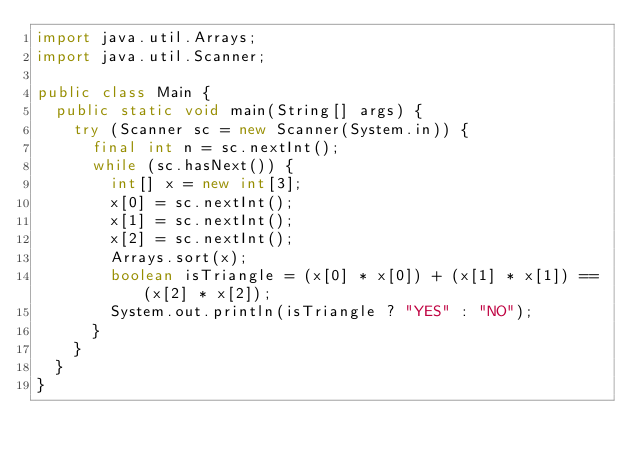<code> <loc_0><loc_0><loc_500><loc_500><_Java_>import java.util.Arrays;
import java.util.Scanner;

public class Main {
	public static void main(String[] args) {
		try (Scanner sc = new Scanner(System.in)) {
			final int n = sc.nextInt();
			while (sc.hasNext()) {
				int[] x = new int[3];
				x[0] = sc.nextInt();
				x[1] = sc.nextInt();
				x[2] = sc.nextInt();
				Arrays.sort(x);
				boolean isTriangle = (x[0] * x[0]) + (x[1] * x[1]) == (x[2] * x[2]);
				System.out.println(isTriangle ? "YES" : "NO");
			}
		}
	}
}</code> 